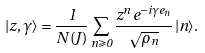Convert formula to latex. <formula><loc_0><loc_0><loc_500><loc_500>| z , \gamma \rangle = \frac { 1 } { N ( J ) } \sum _ { n \geqslant 0 } \frac { z ^ { n } \, e ^ { - i \gamma e _ { n } } } { \sqrt { \rho _ { n } } } \, | n \rangle .</formula> 